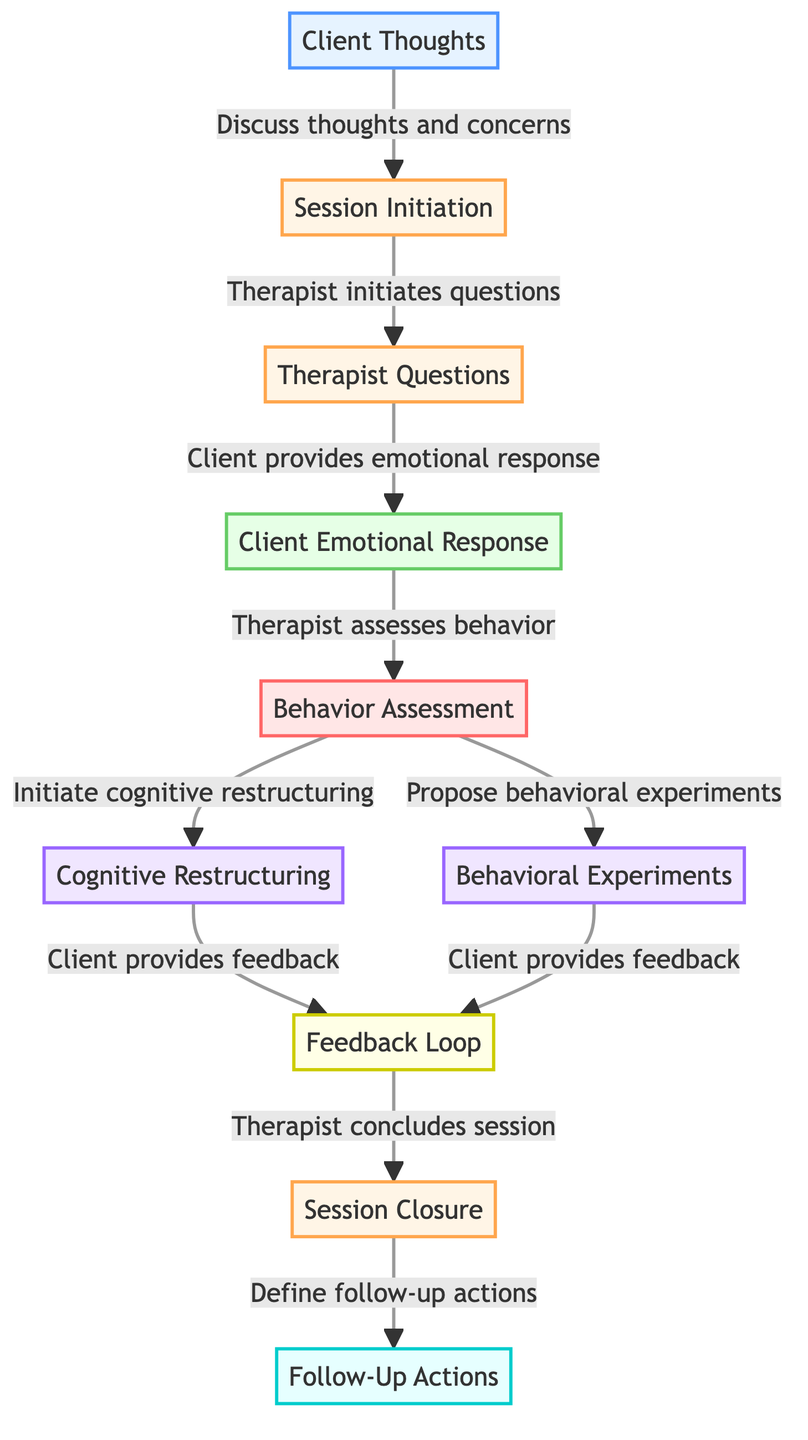What are the types of nodes present in the diagram? The diagram contains source, process, data, analysis, intervention, feedback, and task node types.
Answer: source, process, data, analysis, intervention, feedback, task How many nodes are there in total? By counting the nodes listed in the diagram, we identify a total of ten nodes.
Answer: 10 Which node immediately follows "Therapist Questions"? The edge from "Therapist Questions" points to "Client Emotional Response," indicating that this is the next node in the flow.
Answer: Client Emotional Response What action does the therapist take after initiating cognitive restructuring? Once cognitive restructuring is initiated, the client provides feedback, directly following this step in the flow.
Answer: Client provides feedback How many feedback loops are defined in the diagram? Two loops are indicated, as both "Cognitive Restructuring" and "Behavioral Experiments" lead to the "Feedback Loop."
Answer: 2 What node is the final process in the flow before defining follow-up actions? The "Session Closure" node comes right before "Follow-Up Actions" in the flow, making it the last process prior to follow-up.
Answer: Session Closure Which nodes are categorized as interventions? The interventions in the diagram are "Cognitive Restructuring" and "Behavioral Experiments."
Answer: Cognitive Restructuring, Behavioral Experiments What is the primary input to initiate the session? The diagram shows that "Client Thoughts" serve as the initial input to start the therapeutic process.
Answer: Client Thoughts Which entities provide feedback in the feedback loop? The feedback comes from the client for both cognitive restructuring and behavioral experiments, as shown in the connections labeled "Client provides feedback."
Answer: Client provides feedback 